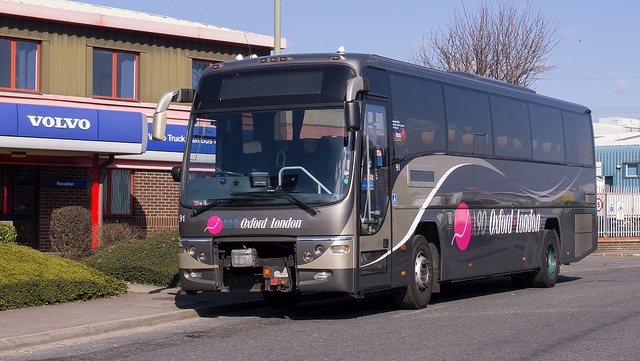Describe the objects in this image and their specific colors. I can see bus in lightgray, gray, black, and darkgray tones in this image. 